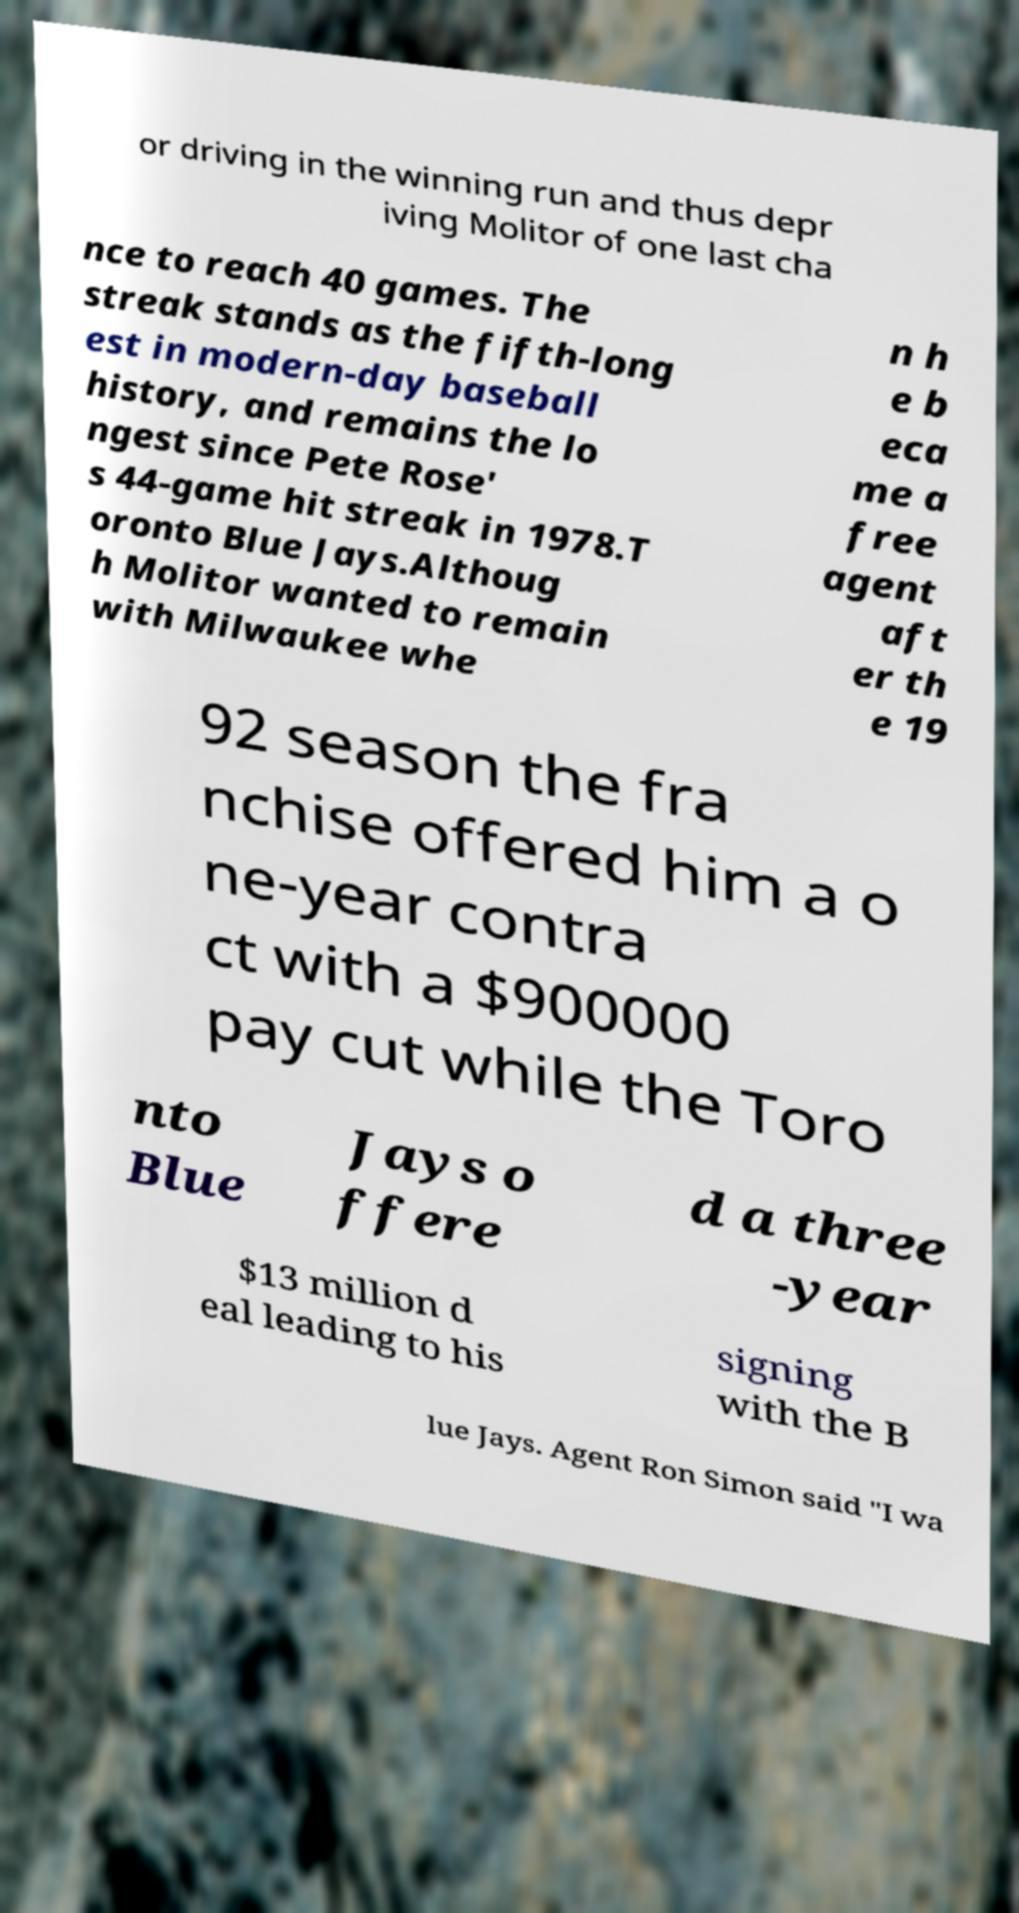Could you extract and type out the text from this image? or driving in the winning run and thus depr iving Molitor of one last cha nce to reach 40 games. The streak stands as the fifth-long est in modern-day baseball history, and remains the lo ngest since Pete Rose' s 44-game hit streak in 1978.T oronto Blue Jays.Althoug h Molitor wanted to remain with Milwaukee whe n h e b eca me a free agent aft er th e 19 92 season the fra nchise offered him a o ne-year contra ct with a $900000 pay cut while the Toro nto Blue Jays o ffere d a three -year $13 million d eal leading to his signing with the B lue Jays. Agent Ron Simon said "I wa 